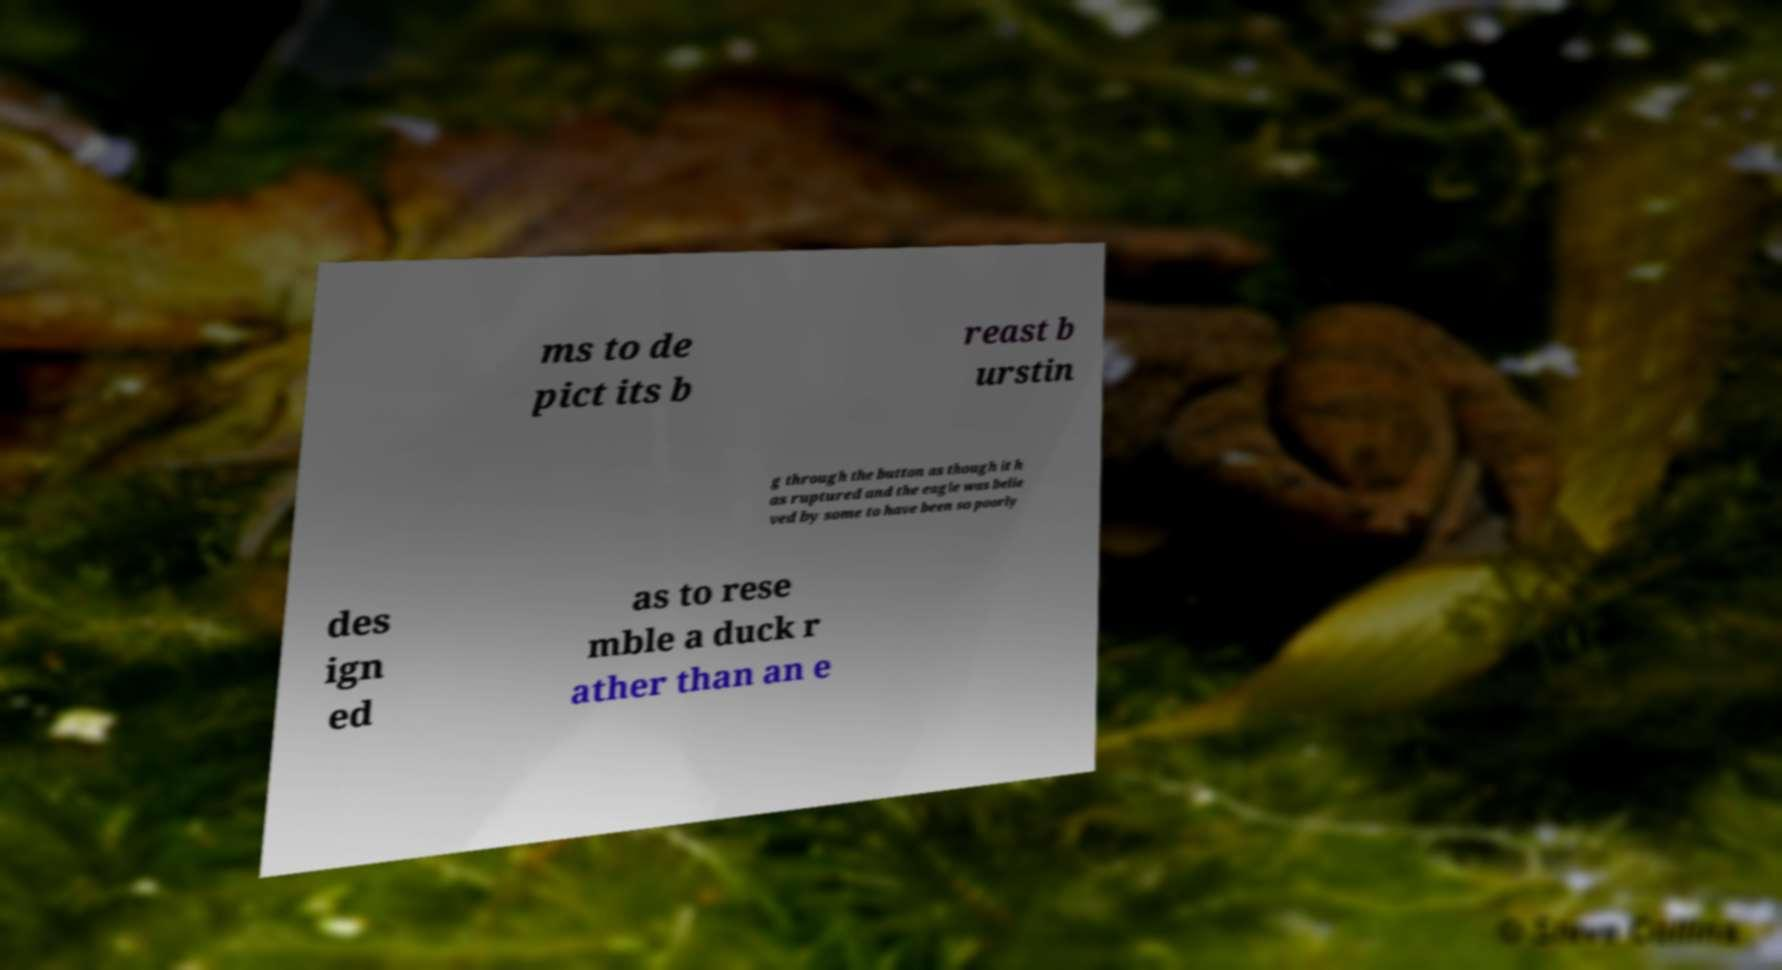Can you accurately transcribe the text from the provided image for me? ms to de pict its b reast b urstin g through the button as though it h as ruptured and the eagle was belie ved by some to have been so poorly des ign ed as to rese mble a duck r ather than an e 